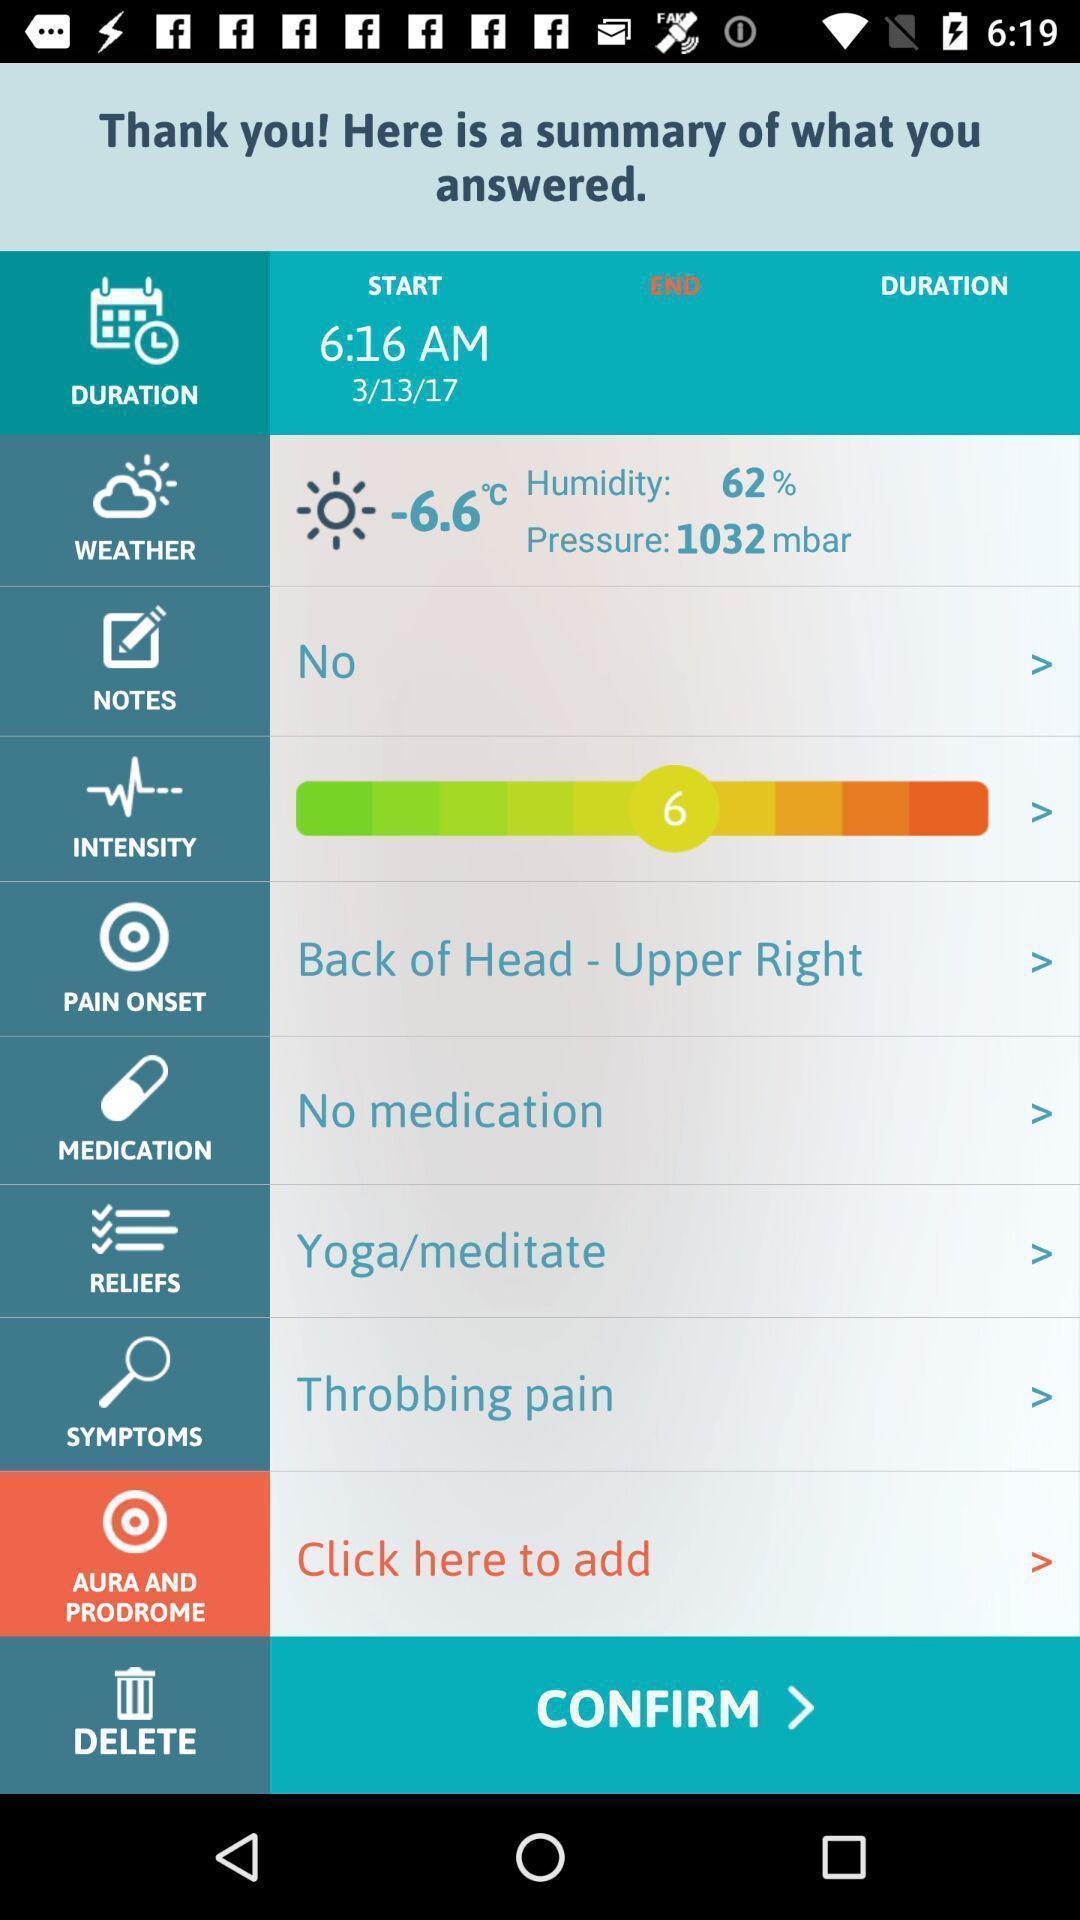Provide a description of this screenshot. Page showing different options on an app. 